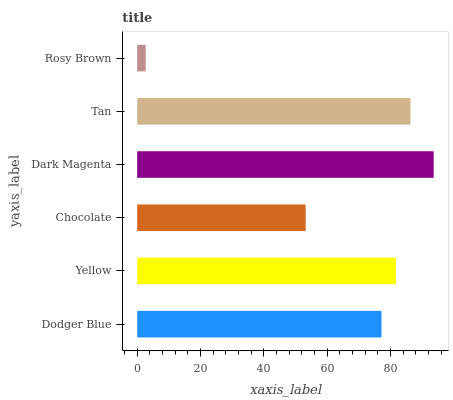Is Rosy Brown the minimum?
Answer yes or no. Yes. Is Dark Magenta the maximum?
Answer yes or no. Yes. Is Yellow the minimum?
Answer yes or no. No. Is Yellow the maximum?
Answer yes or no. No. Is Yellow greater than Dodger Blue?
Answer yes or no. Yes. Is Dodger Blue less than Yellow?
Answer yes or no. Yes. Is Dodger Blue greater than Yellow?
Answer yes or no. No. Is Yellow less than Dodger Blue?
Answer yes or no. No. Is Yellow the high median?
Answer yes or no. Yes. Is Dodger Blue the low median?
Answer yes or no. Yes. Is Dark Magenta the high median?
Answer yes or no. No. Is Dark Magenta the low median?
Answer yes or no. No. 